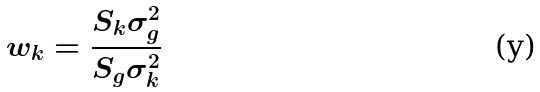<formula> <loc_0><loc_0><loc_500><loc_500>w _ { k } = \frac { S _ { k } \sigma _ { g } ^ { 2 } } { S _ { g } \sigma _ { k } ^ { 2 } }</formula> 